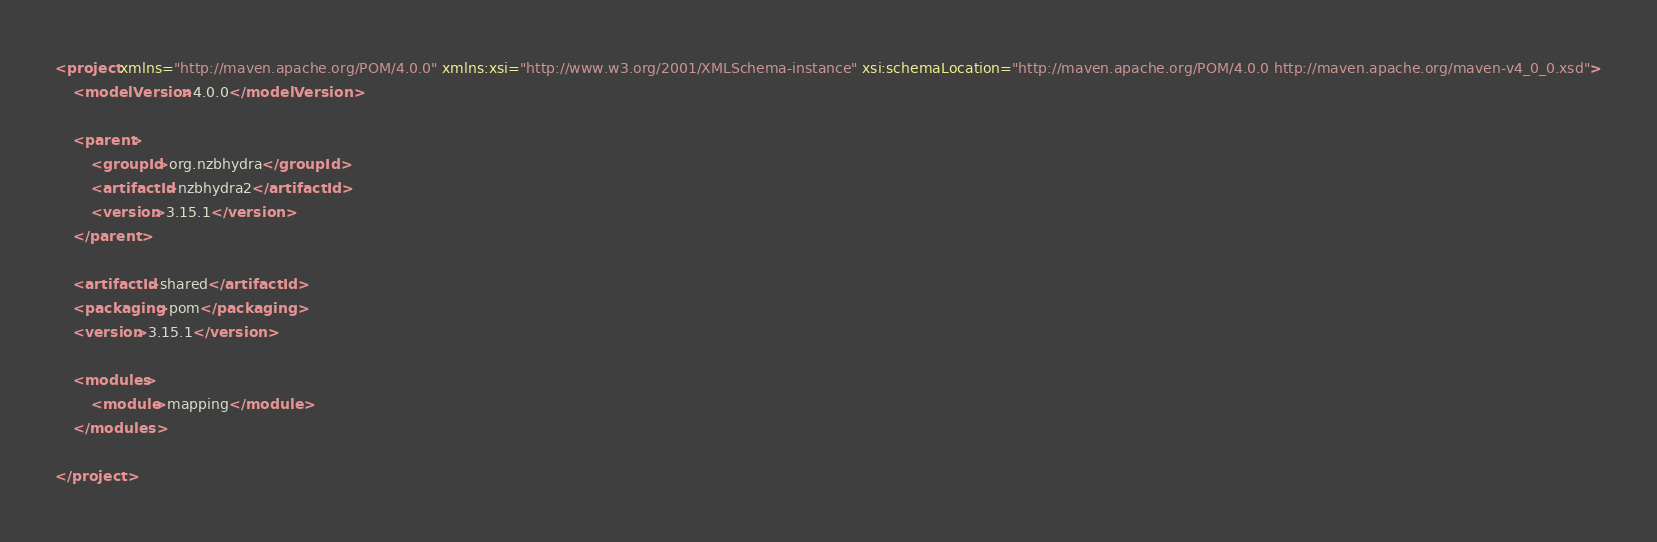Convert code to text. <code><loc_0><loc_0><loc_500><loc_500><_XML_><project xmlns="http://maven.apache.org/POM/4.0.0" xmlns:xsi="http://www.w3.org/2001/XMLSchema-instance" xsi:schemaLocation="http://maven.apache.org/POM/4.0.0 http://maven.apache.org/maven-v4_0_0.xsd">
    <modelVersion>4.0.0</modelVersion>

    <parent>
        <groupId>org.nzbhydra</groupId>
        <artifactId>nzbhydra2</artifactId>
        <version>3.15.1</version>
    </parent>
	
    <artifactId>shared</artifactId>
    <packaging>pom</packaging>
    <version>3.15.1</version>

    <modules>
        <module>mapping</module>
    </modules>

</project></code> 